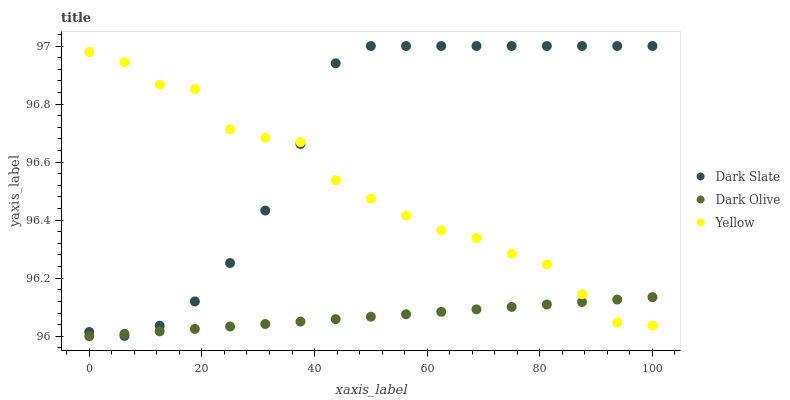Does Dark Olive have the minimum area under the curve?
Answer yes or no. Yes. Does Dark Slate have the maximum area under the curve?
Answer yes or no. Yes. Does Yellow have the minimum area under the curve?
Answer yes or no. No. Does Yellow have the maximum area under the curve?
Answer yes or no. No. Is Dark Olive the smoothest?
Answer yes or no. Yes. Is Yellow the roughest?
Answer yes or no. Yes. Is Yellow the smoothest?
Answer yes or no. No. Is Dark Olive the roughest?
Answer yes or no. No. Does Dark Olive have the lowest value?
Answer yes or no. Yes. Does Yellow have the lowest value?
Answer yes or no. No. Does Dark Slate have the highest value?
Answer yes or no. Yes. Does Yellow have the highest value?
Answer yes or no. No. Does Dark Slate intersect Yellow?
Answer yes or no. Yes. Is Dark Slate less than Yellow?
Answer yes or no. No. Is Dark Slate greater than Yellow?
Answer yes or no. No. 